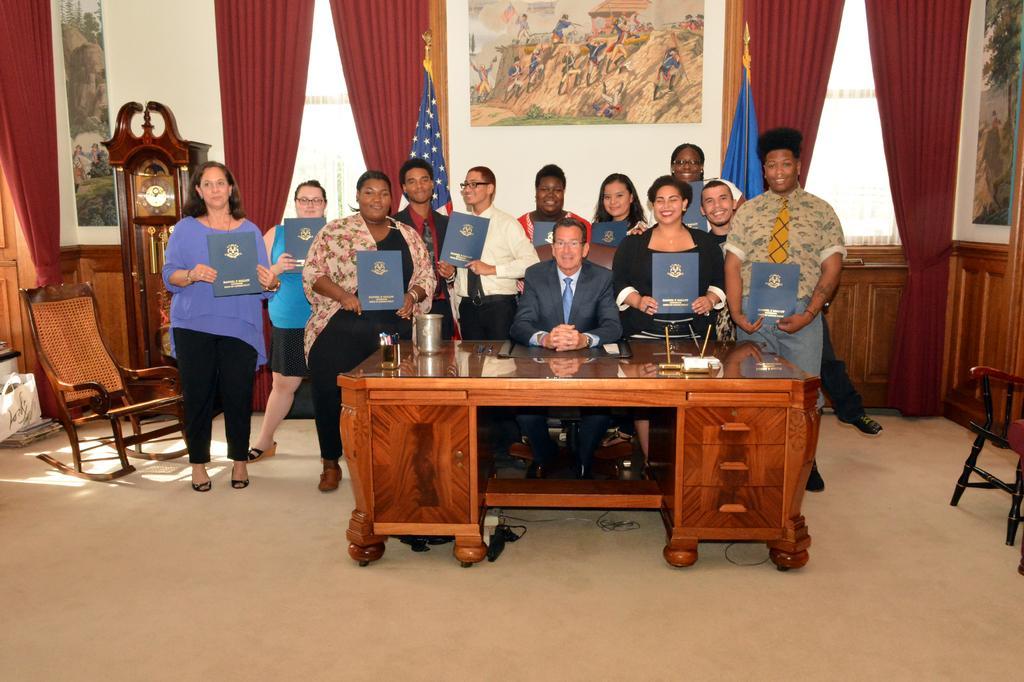Can you describe this image briefly? In this image I can see group of people where everyone is standing and one man is sitting on his chair. I can see smile on few faces. In the background I can see a painting on this wall and few curtains and two flags. I can also see a clock and a chair. 